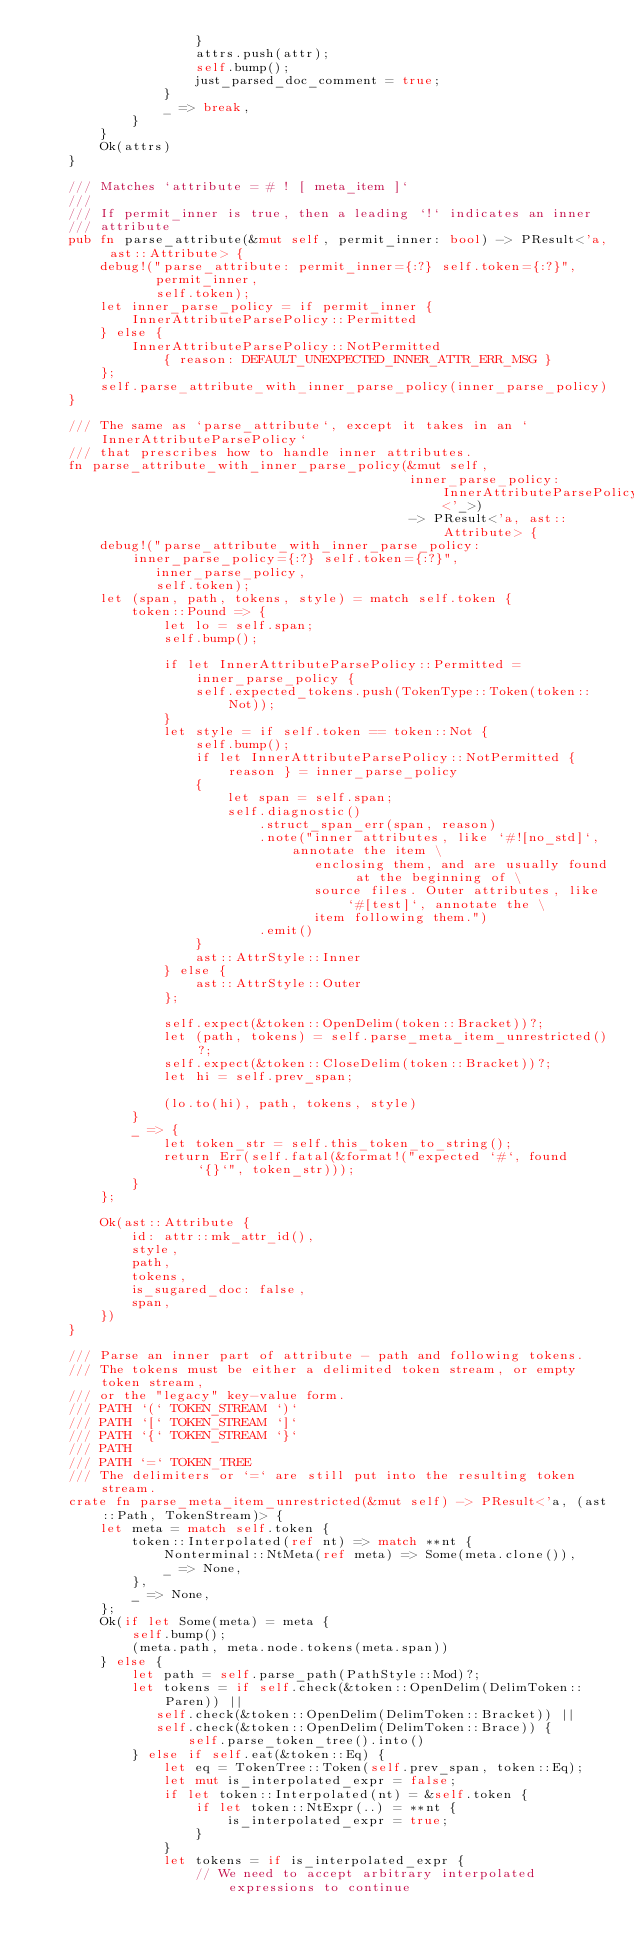Convert code to text. <code><loc_0><loc_0><loc_500><loc_500><_Rust_>                    }
                    attrs.push(attr);
                    self.bump();
                    just_parsed_doc_comment = true;
                }
                _ => break,
            }
        }
        Ok(attrs)
    }

    /// Matches `attribute = # ! [ meta_item ]`
    ///
    /// If permit_inner is true, then a leading `!` indicates an inner
    /// attribute
    pub fn parse_attribute(&mut self, permit_inner: bool) -> PResult<'a, ast::Attribute> {
        debug!("parse_attribute: permit_inner={:?} self.token={:?}",
               permit_inner,
               self.token);
        let inner_parse_policy = if permit_inner {
            InnerAttributeParsePolicy::Permitted
        } else {
            InnerAttributeParsePolicy::NotPermitted
                { reason: DEFAULT_UNEXPECTED_INNER_ATTR_ERR_MSG }
        };
        self.parse_attribute_with_inner_parse_policy(inner_parse_policy)
    }

    /// The same as `parse_attribute`, except it takes in an `InnerAttributeParsePolicy`
    /// that prescribes how to handle inner attributes.
    fn parse_attribute_with_inner_parse_policy(&mut self,
                                               inner_parse_policy: InnerAttributeParsePolicy<'_>)
                                               -> PResult<'a, ast::Attribute> {
        debug!("parse_attribute_with_inner_parse_policy: inner_parse_policy={:?} self.token={:?}",
               inner_parse_policy,
               self.token);
        let (span, path, tokens, style) = match self.token {
            token::Pound => {
                let lo = self.span;
                self.bump();

                if let InnerAttributeParsePolicy::Permitted = inner_parse_policy {
                    self.expected_tokens.push(TokenType::Token(token::Not));
                }
                let style = if self.token == token::Not {
                    self.bump();
                    if let InnerAttributeParsePolicy::NotPermitted { reason } = inner_parse_policy
                    {
                        let span = self.span;
                        self.diagnostic()
                            .struct_span_err(span, reason)
                            .note("inner attributes, like `#![no_std]`, annotate the item \
                                   enclosing them, and are usually found at the beginning of \
                                   source files. Outer attributes, like `#[test]`, annotate the \
                                   item following them.")
                            .emit()
                    }
                    ast::AttrStyle::Inner
                } else {
                    ast::AttrStyle::Outer
                };

                self.expect(&token::OpenDelim(token::Bracket))?;
                let (path, tokens) = self.parse_meta_item_unrestricted()?;
                self.expect(&token::CloseDelim(token::Bracket))?;
                let hi = self.prev_span;

                (lo.to(hi), path, tokens, style)
            }
            _ => {
                let token_str = self.this_token_to_string();
                return Err(self.fatal(&format!("expected `#`, found `{}`", token_str)));
            }
        };

        Ok(ast::Attribute {
            id: attr::mk_attr_id(),
            style,
            path,
            tokens,
            is_sugared_doc: false,
            span,
        })
    }

    /// Parse an inner part of attribute - path and following tokens.
    /// The tokens must be either a delimited token stream, or empty token stream,
    /// or the "legacy" key-value form.
    /// PATH `(` TOKEN_STREAM `)`
    /// PATH `[` TOKEN_STREAM `]`
    /// PATH `{` TOKEN_STREAM `}`
    /// PATH
    /// PATH `=` TOKEN_TREE
    /// The delimiters or `=` are still put into the resulting token stream.
    crate fn parse_meta_item_unrestricted(&mut self) -> PResult<'a, (ast::Path, TokenStream)> {
        let meta = match self.token {
            token::Interpolated(ref nt) => match **nt {
                Nonterminal::NtMeta(ref meta) => Some(meta.clone()),
                _ => None,
            },
            _ => None,
        };
        Ok(if let Some(meta) = meta {
            self.bump();
            (meta.path, meta.node.tokens(meta.span))
        } else {
            let path = self.parse_path(PathStyle::Mod)?;
            let tokens = if self.check(&token::OpenDelim(DelimToken::Paren)) ||
               self.check(&token::OpenDelim(DelimToken::Bracket)) ||
               self.check(&token::OpenDelim(DelimToken::Brace)) {
                   self.parse_token_tree().into()
            } else if self.eat(&token::Eq) {
                let eq = TokenTree::Token(self.prev_span, token::Eq);
                let mut is_interpolated_expr = false;
                if let token::Interpolated(nt) = &self.token {
                    if let token::NtExpr(..) = **nt {
                        is_interpolated_expr = true;
                    }
                }
                let tokens = if is_interpolated_expr {
                    // We need to accept arbitrary interpolated expressions to continue</code> 